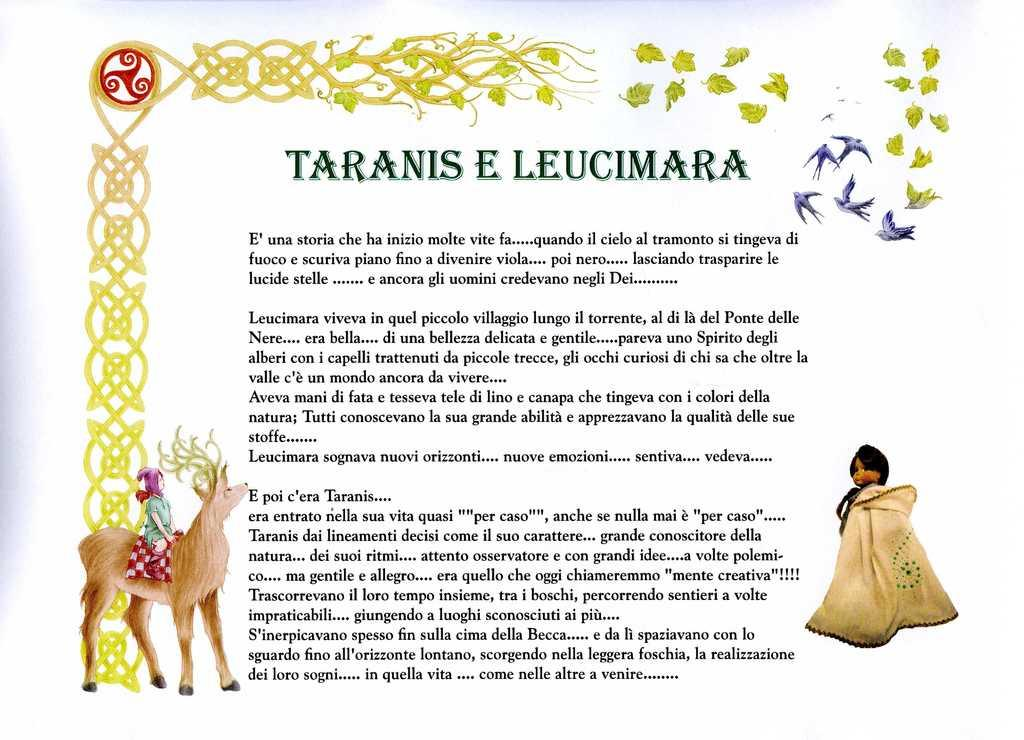What type of medium is the image presented on? The image appears to be printed. What can be found within the image besides visual elements? There is text in the image. What type of animals are depicted in the image? There are birds in the image. What is the person in the image doing? A person is sitting on an animal in the image. Who else is present in the image? A woman is present in the image. What is the woman's belief about the boundary of the sink in the image? There is no sink present in the image, so it is not possible to determine the woman's belief about its boundary. 